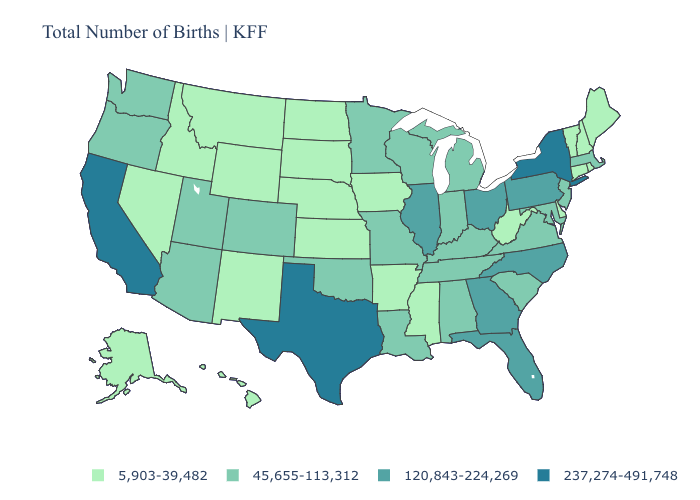Does the map have missing data?
Answer briefly. No. What is the value of Oklahoma?
Answer briefly. 45,655-113,312. What is the highest value in the South ?
Be succinct. 237,274-491,748. What is the lowest value in the USA?
Quick response, please. 5,903-39,482. Among the states that border South Dakota , does Minnesota have the lowest value?
Be succinct. No. How many symbols are there in the legend?
Short answer required. 4. Name the states that have a value in the range 237,274-491,748?
Be succinct. California, New York, Texas. Among the states that border Colorado , which have the lowest value?
Give a very brief answer. Kansas, Nebraska, New Mexico, Wyoming. Which states have the lowest value in the MidWest?
Short answer required. Iowa, Kansas, Nebraska, North Dakota, South Dakota. What is the value of Delaware?
Answer briefly. 5,903-39,482. What is the lowest value in the USA?
Give a very brief answer. 5,903-39,482. Name the states that have a value in the range 237,274-491,748?
Quick response, please. California, New York, Texas. What is the highest value in the MidWest ?
Write a very short answer. 120,843-224,269. What is the value of Alaska?
Answer briefly. 5,903-39,482. Does California have the highest value in the USA?
Write a very short answer. Yes. 